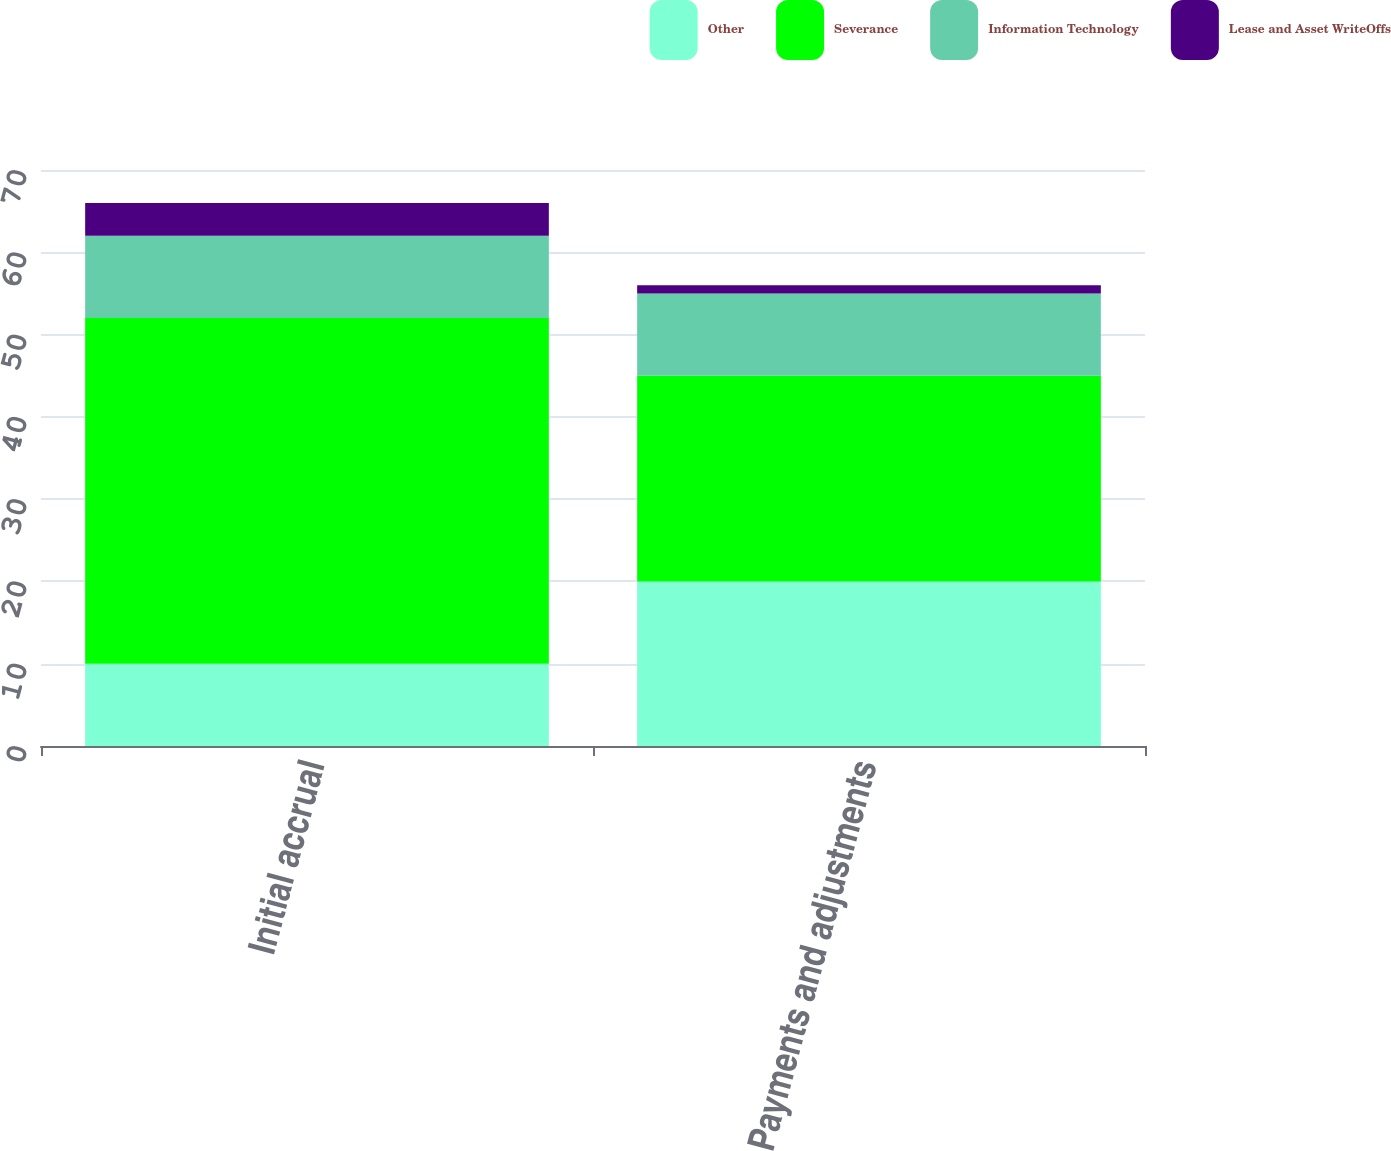Convert chart. <chart><loc_0><loc_0><loc_500><loc_500><stacked_bar_chart><ecel><fcel>Initial accrual<fcel>Payments and adjustments<nl><fcel>Other<fcel>10<fcel>20<nl><fcel>Severance<fcel>42<fcel>25<nl><fcel>Information Technology<fcel>10<fcel>10<nl><fcel>Lease and Asset WriteOffs<fcel>4<fcel>1<nl></chart> 